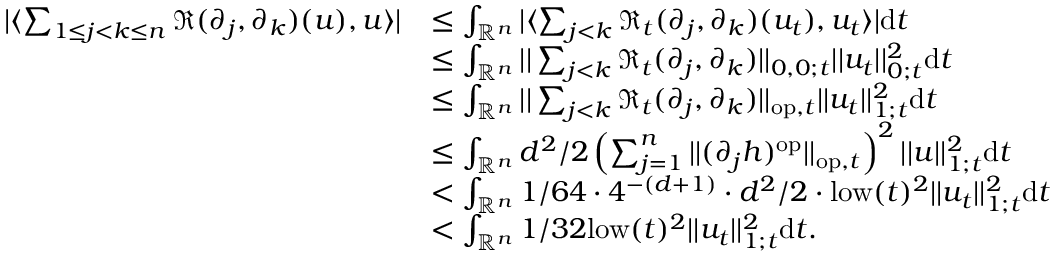<formula> <loc_0><loc_0><loc_500><loc_500>\begin{array} { r l } { | \langle \sum _ { 1 \leq j < k \leq n } \mathfrak { R } ( \partial _ { j } , \partial _ { k } ) ( u ) , u \rangle | } & { \leq \int _ { \mathbb { R } ^ { n } } | \langle \sum _ { j < k } \mathfrak { R } _ { t } ( \partial _ { j } , \partial _ { k } ) ( u _ { t } ) , u _ { t } \rangle | d t } \\ & { \leq \int _ { \mathbb { R } ^ { n } } | | \sum _ { j < k } \mathfrak { R } _ { t } ( \partial _ { j } , \partial _ { k } ) | | _ { 0 , 0 ; t } | | u _ { t } | | _ { 0 ; t } ^ { 2 } d t } \\ & { \leq \int _ { \mathbb { R } ^ { n } } | | \sum _ { j < k } \mathfrak { R } _ { t } ( \partial _ { j } , \partial _ { k } ) | | _ { o p , t } | | u _ { t } | | _ { 1 ; t } ^ { 2 } d t } \\ & { \leq \int _ { \mathbb { R } ^ { n } } d ^ { 2 } / 2 \left ( \sum _ { j = 1 } ^ { n } | | ( \partial _ { j } h ) ^ { o p } | | _ { o p , t } \right ) ^ { 2 } | | u | | _ { 1 ; t } ^ { 2 } d t } \\ & { < \int _ { \mathbb { R } ^ { n } } 1 / 6 4 \cdot 4 ^ { - ( d + 1 ) } \cdot d ^ { 2 } / 2 \cdot l o w ( t ) ^ { 2 } | | u _ { t } | | _ { 1 ; t } ^ { 2 } d t } \\ & { < \int _ { \mathbb { R } ^ { n } } 1 / 3 2 l o w ( t ) ^ { 2 } | | u _ { t } | | _ { 1 ; t } ^ { 2 } d t . } \end{array}</formula> 